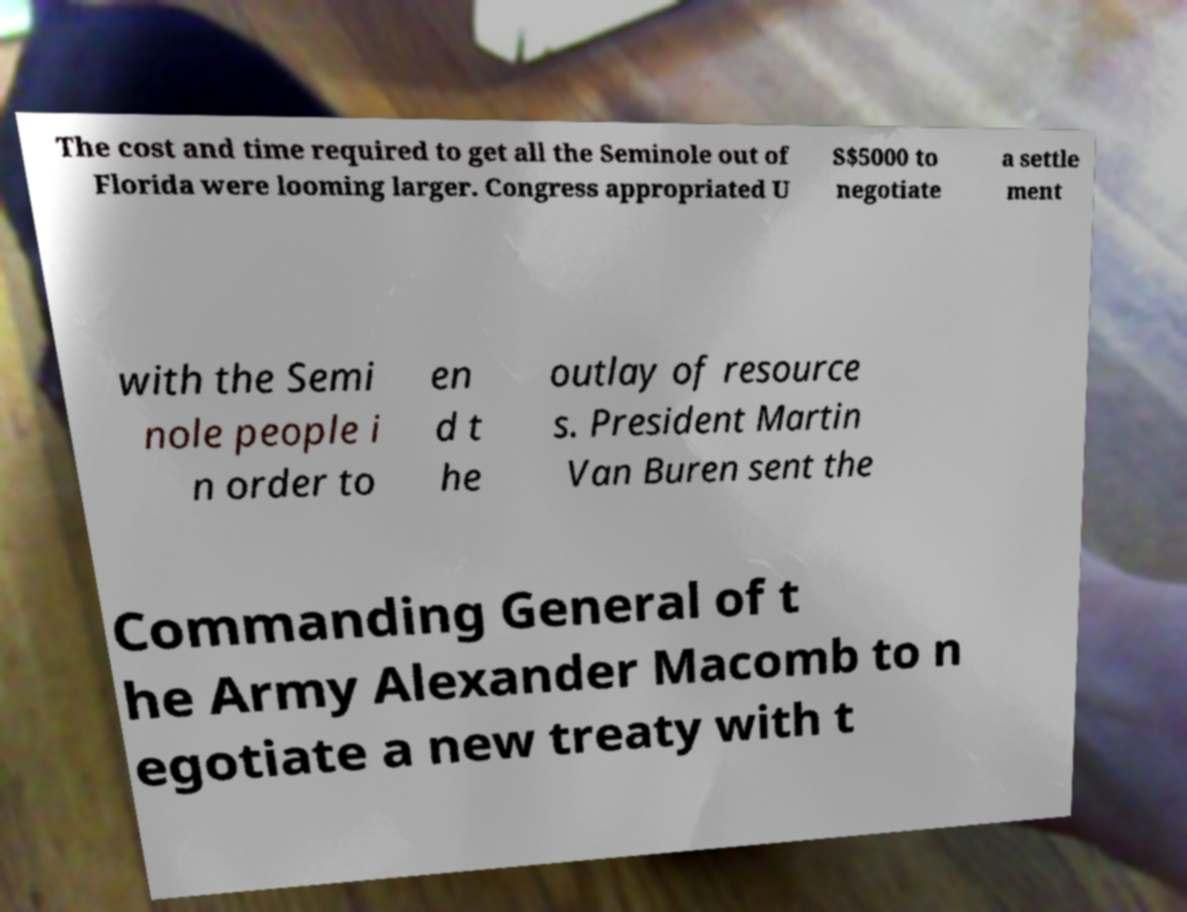I need the written content from this picture converted into text. Can you do that? The cost and time required to get all the Seminole out of Florida were looming larger. Congress appropriated U S$5000 to negotiate a settle ment with the Semi nole people i n order to en d t he outlay of resource s. President Martin Van Buren sent the Commanding General of t he Army Alexander Macomb to n egotiate a new treaty with t 